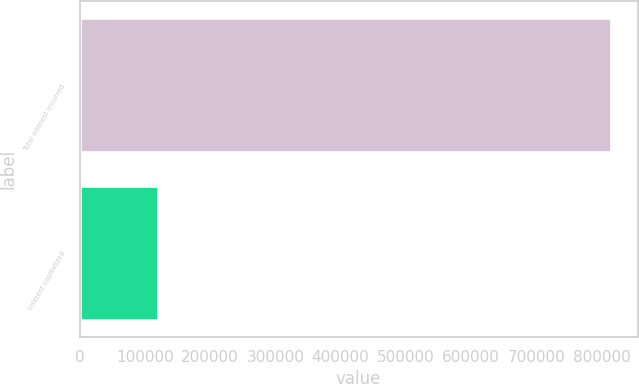Convert chart. <chart><loc_0><loc_0><loc_500><loc_500><bar_chart><fcel>Total interest incurred<fcel>Interest capitalized<nl><fcel>814731<fcel>119958<nl></chart> 